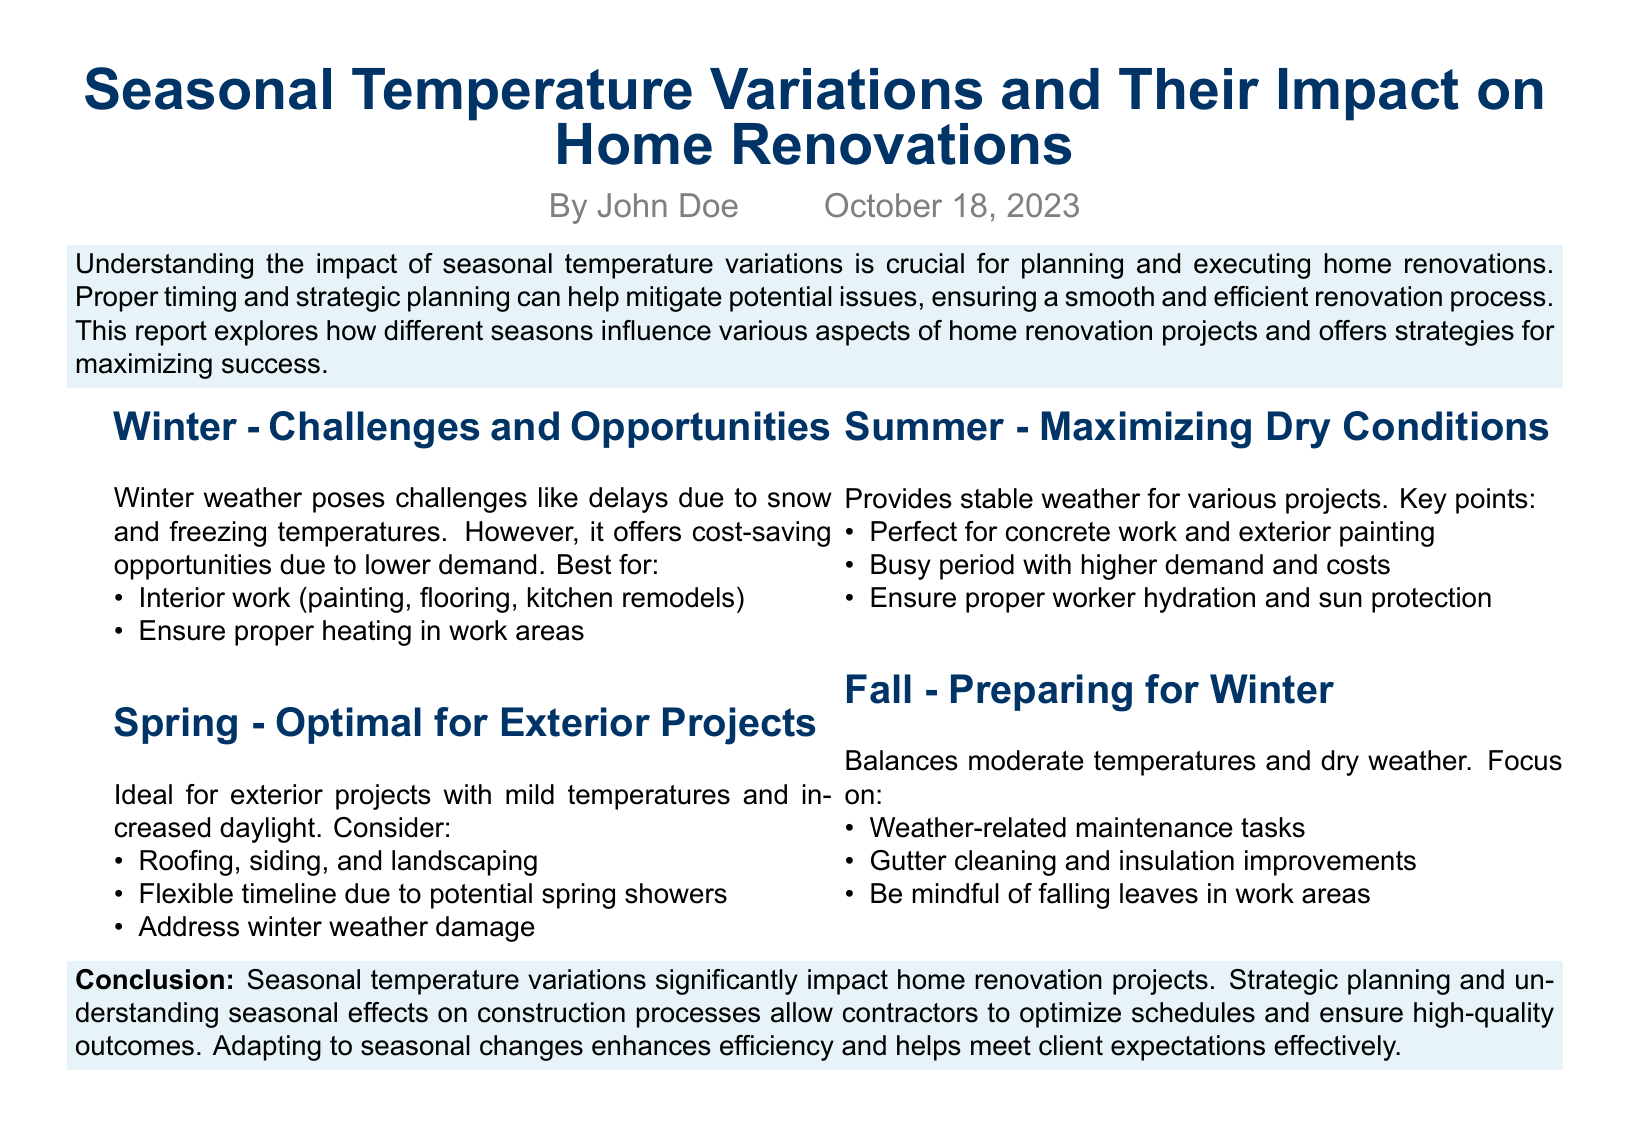What are the main challenges of winter for home renovations? The document states that winter weather poses challenges like delays due to snow and freezing temperatures.
Answer: Delays due to snow and freezing temperatures What season is considered optimal for exterior projects? The report mentions that spring is ideal for exterior projects with mild temperatures and increased daylight.
Answer: Spring What is suggested for summer projects? The document advises that summer provides stable weather for various projects and is perfect for concrete work and exterior painting.
Answer: Concrete work and exterior painting What maintenance tasks are recommended for fall? The document highlights that fall focuses on weather-related maintenance tasks such as gutter cleaning and insulation improvements.
Answer: Gutter cleaning and insulation improvements What is a key opportunity during winter renovations? The report notes that winter offers cost-saving opportunities due to lower demand.
Answer: Cost-saving opportunities What is a consideration for spring renovations? The document indicates that contractors should have a flexible timeline due to potential spring showers.
Answer: Flexible timeline due to potential spring showers What should contractors ensure during summer? The document recommends ensuring proper worker hydration and sun protection during summer renovations.
Answer: Proper worker hydration and sun protection What is the conclusion about seasonal temperature variations? The conclusion emphasizes that seasonal temperature variations significantly impact home renovation projects.
Answer: Significantly impact home renovation projects 